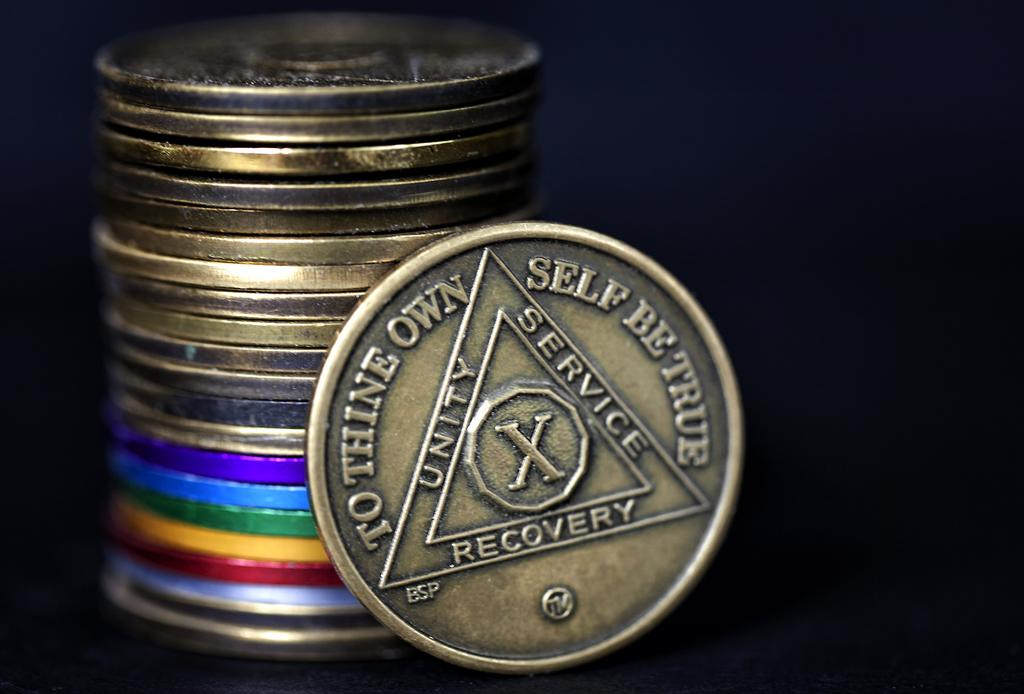Provide a one-sentence caption for the provided image. brass coins stacked up and one reads "To thine own self be true". 